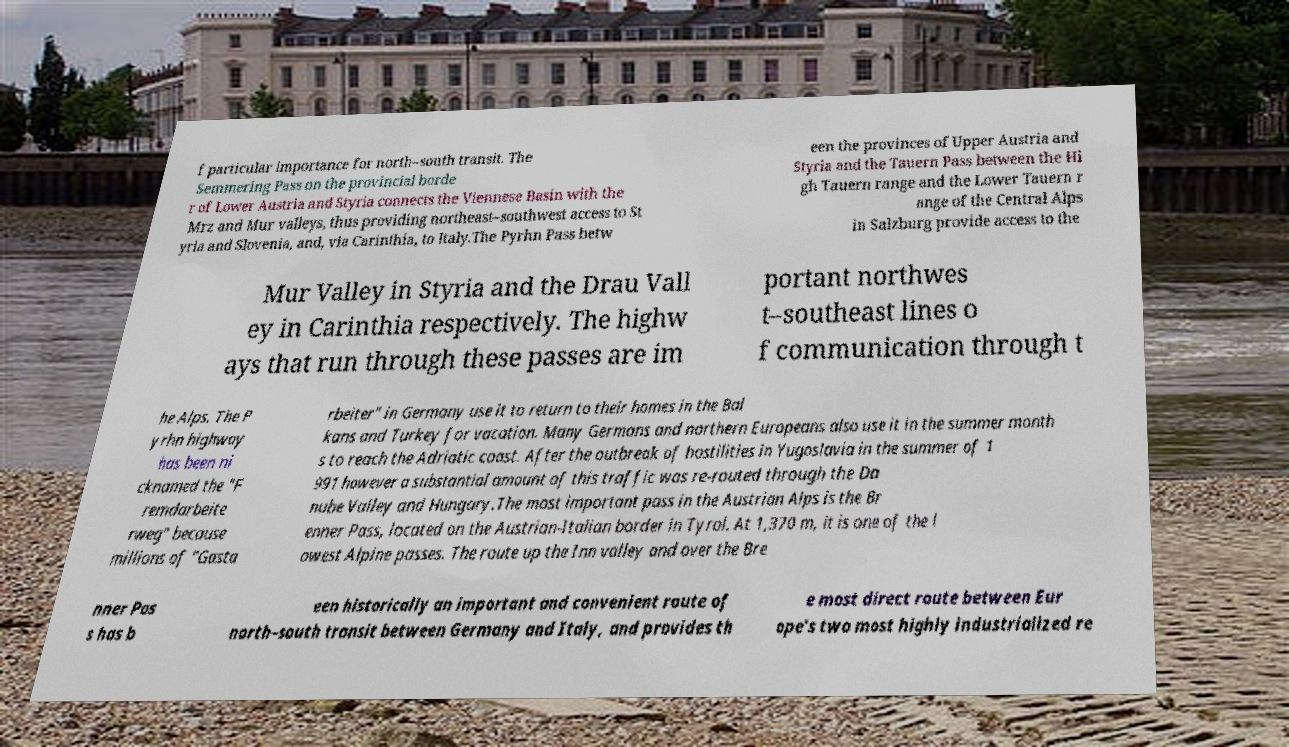Could you assist in decoding the text presented in this image and type it out clearly? f particular importance for north–south transit. The Semmering Pass on the provincial borde r of Lower Austria and Styria connects the Viennese Basin with the Mrz and Mur valleys, thus providing northeast–southwest access to St yria and Slovenia, and, via Carinthia, to Italy.The Pyrhn Pass betw een the provinces of Upper Austria and Styria and the Tauern Pass between the Hi gh Tauern range and the Lower Tauern r ange of the Central Alps in Salzburg provide access to the Mur Valley in Styria and the Drau Vall ey in Carinthia respectively. The highw ays that run through these passes are im portant northwes t–southeast lines o f communication through t he Alps. The P yrhn highway has been ni cknamed the "F remdarbeite rweg" because millions of "Gasta rbeiter" in Germany use it to return to their homes in the Bal kans and Turkey for vacation. Many Germans and northern Europeans also use it in the summer month s to reach the Adriatic coast. After the outbreak of hostilities in Yugoslavia in the summer of 1 991 however a substantial amount of this traffic was re-routed through the Da nube Valley and Hungary.The most important pass in the Austrian Alps is the Br enner Pass, located on the Austrian-Italian border in Tyrol. At 1,370 m, it is one of the l owest Alpine passes. The route up the Inn valley and over the Bre nner Pas s has b een historically an important and convenient route of north–south transit between Germany and Italy, and provides th e most direct route between Eur ope's two most highly industrialized re 